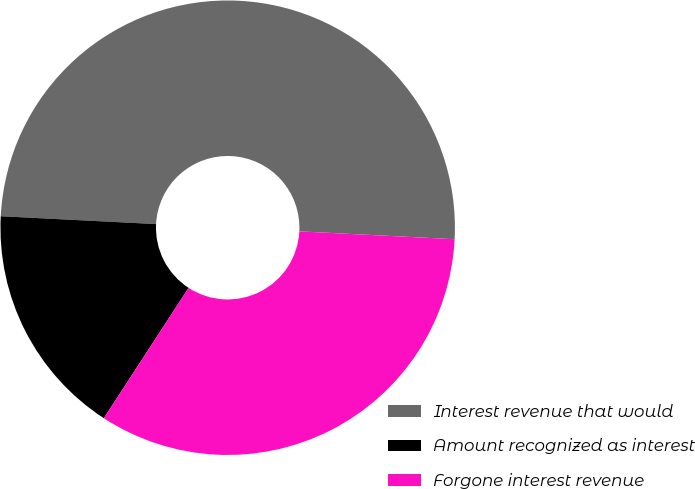<chart> <loc_0><loc_0><loc_500><loc_500><pie_chart><fcel>Interest revenue that would<fcel>Amount recognized as interest<fcel>Forgone interest revenue<nl><fcel>50.0%<fcel>16.63%<fcel>33.37%<nl></chart> 